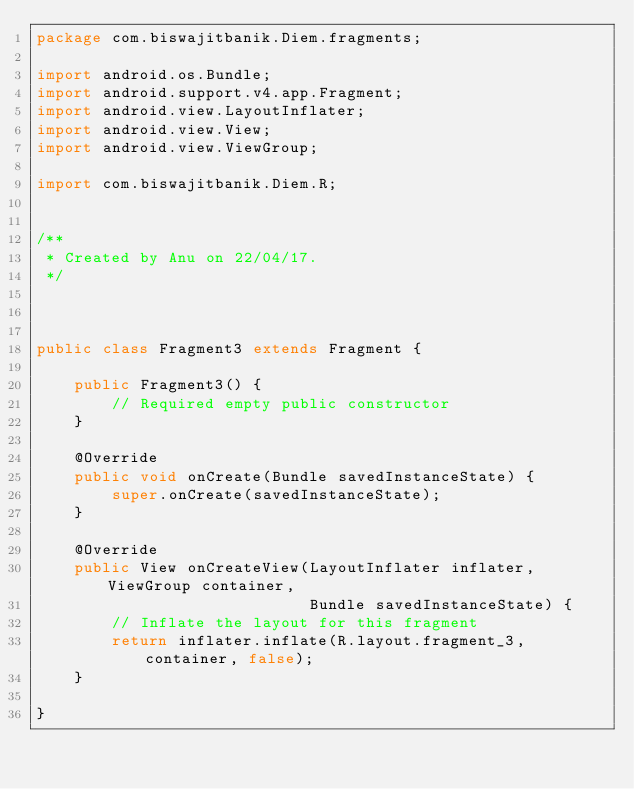<code> <loc_0><loc_0><loc_500><loc_500><_Java_>package com.biswajitbanik.Diem.fragments;

import android.os.Bundle;
import android.support.v4.app.Fragment;
import android.view.LayoutInflater;
import android.view.View;
import android.view.ViewGroup;

import com.biswajitbanik.Diem.R;


/**
 * Created by Anu on 22/04/17.
 */



public class Fragment3 extends Fragment {

    public Fragment3() {
        // Required empty public constructor
    }

    @Override
    public void onCreate(Bundle savedInstanceState) {
        super.onCreate(savedInstanceState);
    }

    @Override
    public View onCreateView(LayoutInflater inflater, ViewGroup container,
                             Bundle savedInstanceState) {
        // Inflate the layout for this fragment
        return inflater.inflate(R.layout.fragment_3, container, false);
    }

}</code> 